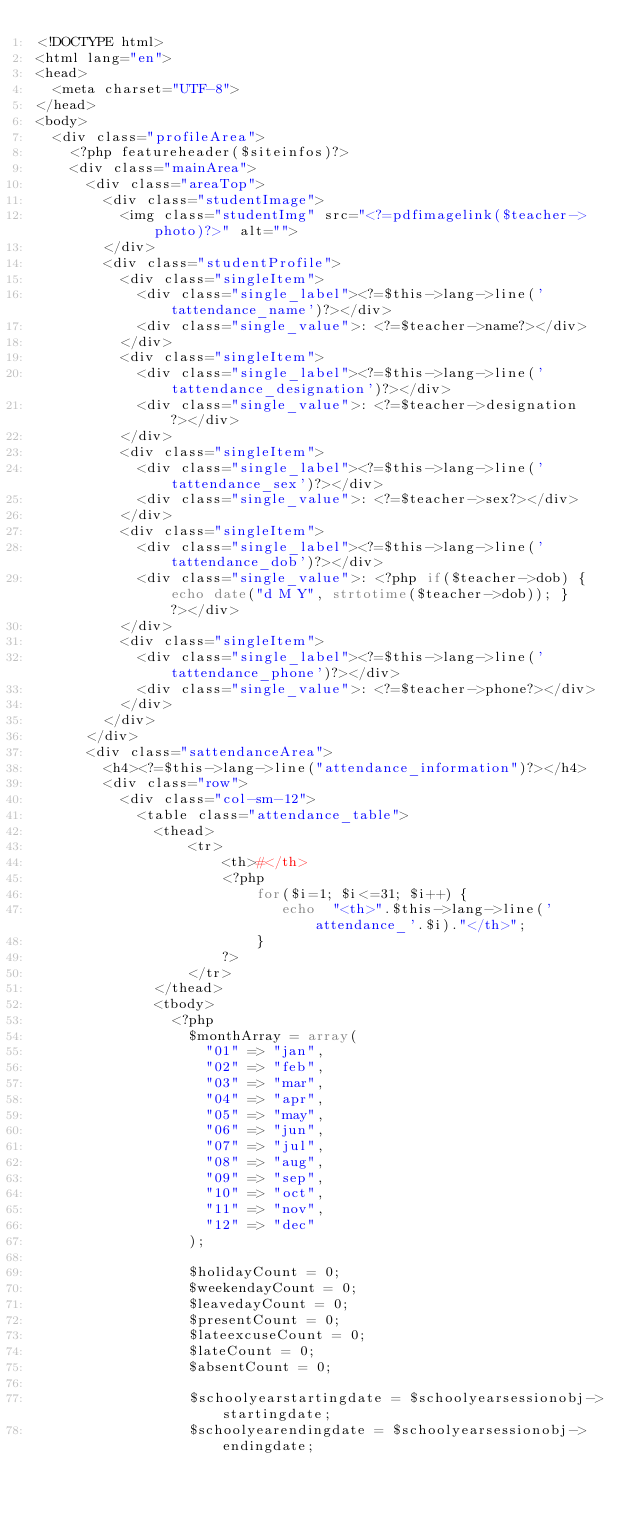<code> <loc_0><loc_0><loc_500><loc_500><_PHP_><!DOCTYPE html>
<html lang="en">
<head>
  <meta charset="UTF-8">
</head>
<body>
  <div class="profileArea">
    <?php featureheader($siteinfos)?>
    <div class="mainArea">
      <div class="areaTop">
        <div class="studentImage">
          <img class="studentImg" src="<?=pdfimagelink($teacher->photo)?>" alt="">
        </div>
        <div class="studentProfile">
          <div class="singleItem">
            <div class="single_label"><?=$this->lang->line('tattendance_name')?></div>
            <div class="single_value">: <?=$teacher->name?></div>
          </div>
          <div class="singleItem">
            <div class="single_label"><?=$this->lang->line('tattendance_designation')?></div>
            <div class="single_value">: <?=$teacher->designation?></div>
          </div>
          <div class="singleItem">
            <div class="single_label"><?=$this->lang->line('tattendance_sex')?></div>
            <div class="single_value">: <?=$teacher->sex?></div>
          </div>
          <div class="singleItem">
            <div class="single_label"><?=$this->lang->line('tattendance_dob')?></div>
            <div class="single_value">: <?php if($teacher->dob) { echo date("d M Y", strtotime($teacher->dob)); } ?></div>
          </div>
          <div class="singleItem">
            <div class="single_label"><?=$this->lang->line('tattendance_phone')?></div>
            <div class="single_value">: <?=$teacher->phone?></div>
          </div>
        </div>
      </div>
      <div class="sattendanceArea">
        <h4><?=$this->lang->line("attendance_information")?></h4>
        <div class="row">
          <div class="col-sm-12">
            <table class="attendance_table">
              <thead>
                  <tr>
                      <th>#</th>
                      <?php
                          for($i=1; $i<=31; $i++) {
                             echo  "<th>".$this->lang->line('attendance_'.$i)."</th>";
                          }
                      ?>
                  </tr>
              </thead>
              <tbody>
                <?php
                  $monthArray = array(
                    "01" => "jan",
                    "02" => "feb",
                    "03" => "mar",
                    "04" => "apr",
                    "05" => "may",
                    "06" => "jun",
                    "07" => "jul",
                    "08" => "aug",
                    "09" => "sep",
                    "10" => "oct",
                    "11" => "nov",
                    "12" => "dec"
                  );

                  $holidayCount = 0;
                  $weekendayCount = 0;
                  $leavedayCount = 0;
                  $presentCount = 0;
                  $lateexcuseCount = 0;
                  $lateCount = 0;
                  $absentCount = 0;

                  $schoolyearstartingdate = $schoolyearsessionobj->startingdate;
                  $schoolyearendingdate = $schoolyearsessionobj->endingdate;</code> 